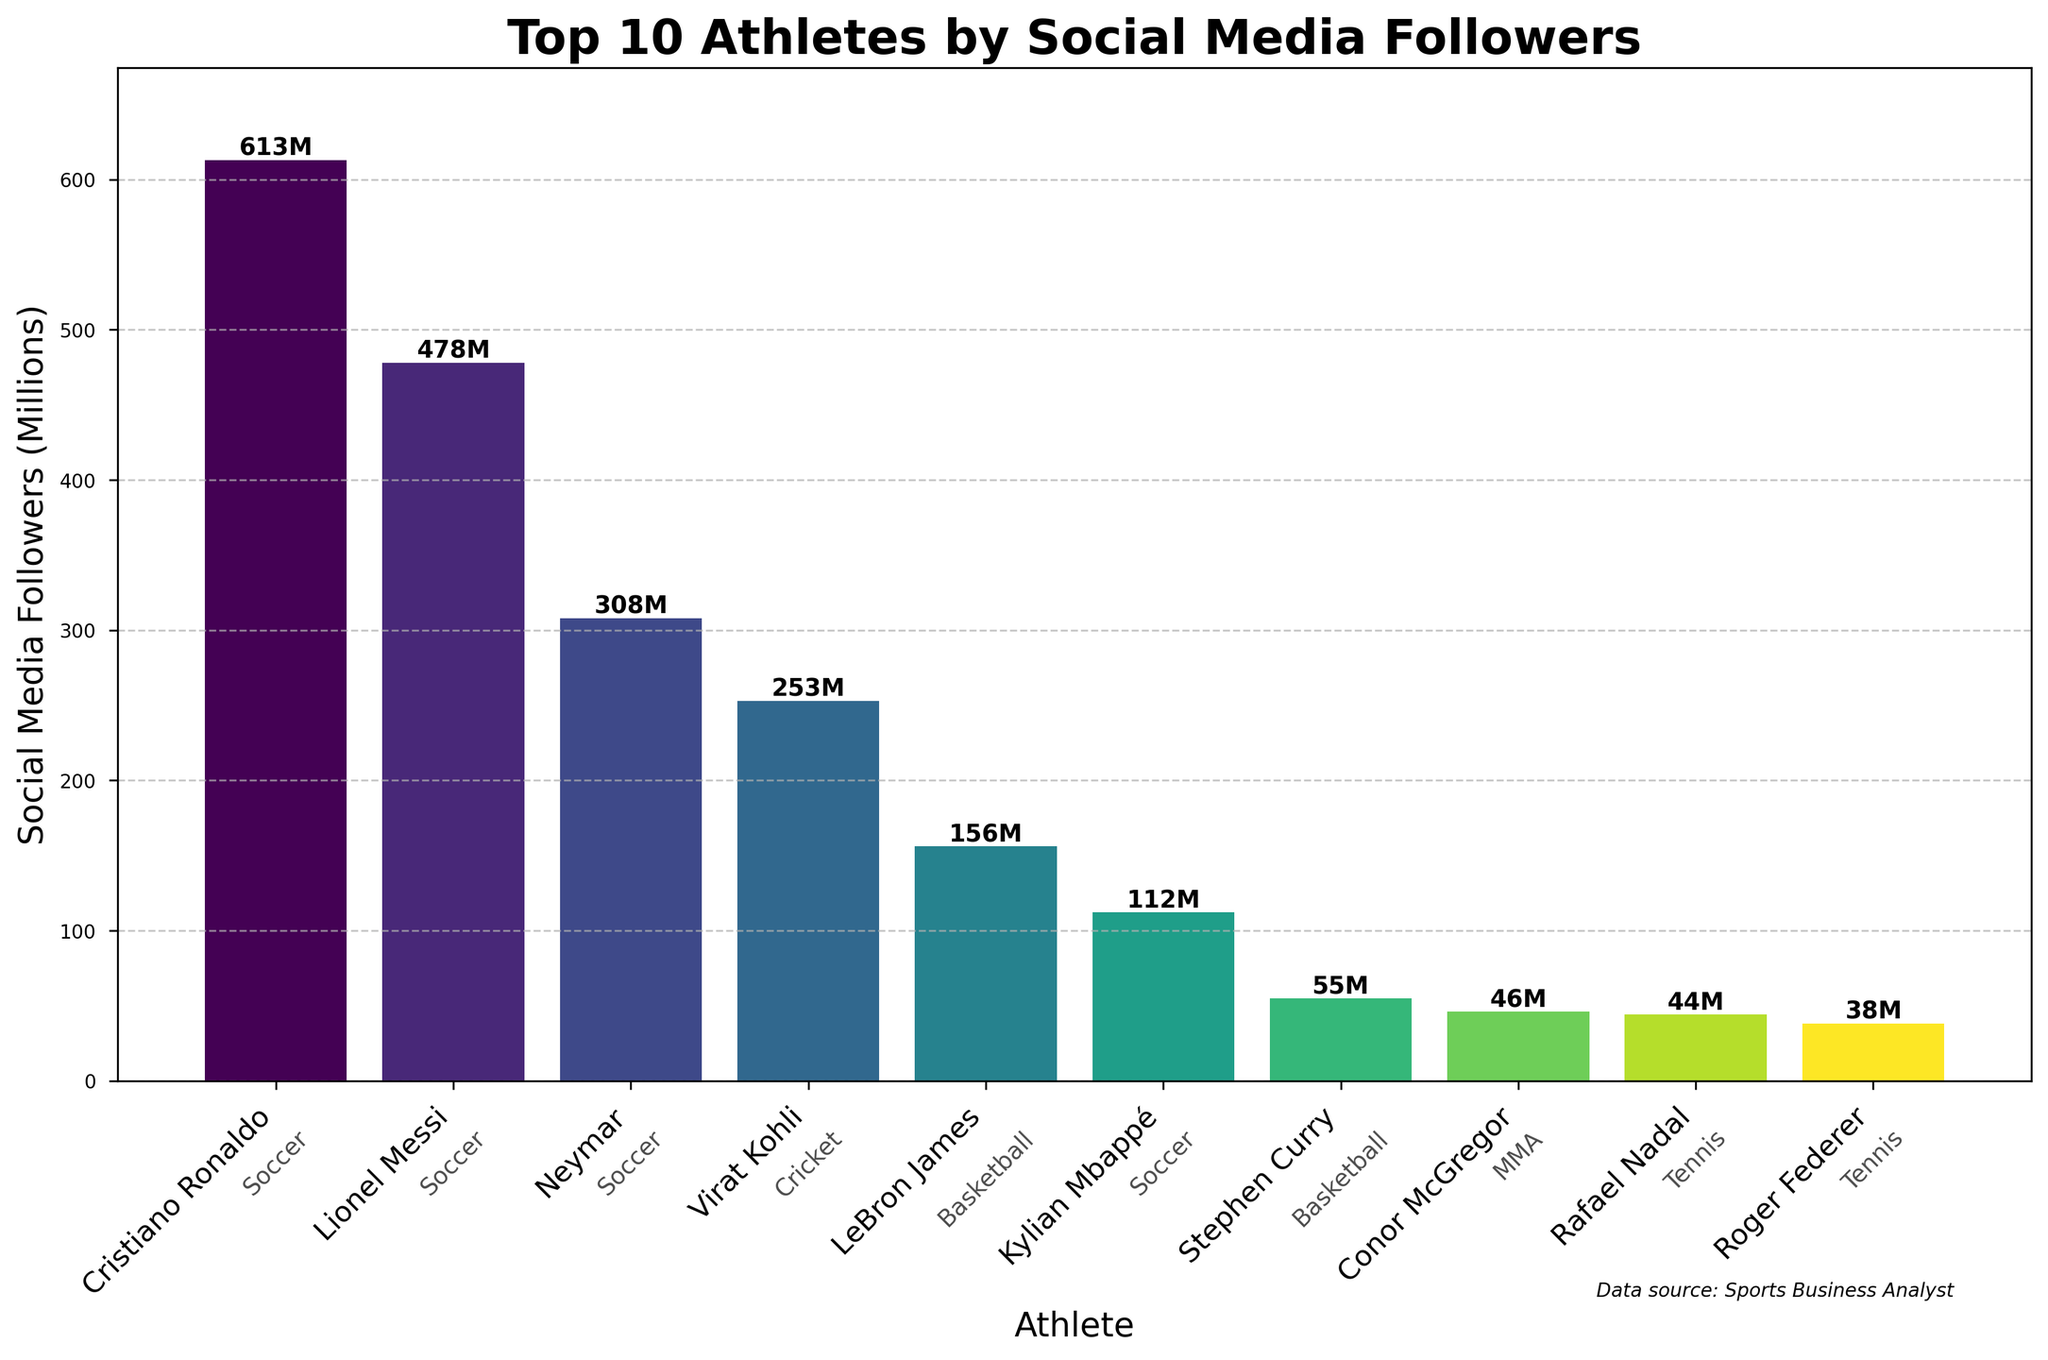Which athlete has the most social media followers? The highest bar in the chart represents Cristiano Ronaldo who has 613 million followers.
Answer: Cristiano Ronaldo Which sport appears most frequently among the top 10 athletes by social media followers? By looking at the sports annotated text at the base of the bars, "Soccer" appears the most frequently. There are four soccer players in the top 10.
Answer: Soccer What is the difference in social media followers between Lionel Messi and Virat Kohli? According to the chart, Lionel Messi has 478 million followers, and Virat Kohli has 253 million. The difference is calculated as 478M - 253M.
Answer: 225 million What’s the combined followers count for all soccer players in the top 10? Summing the followers of Cristiano Ronaldo (613M), Lionel Messi (478M), Neymar (308M), and Kylian Mbappé (112M): 613 + 478 + 308 + 112 = 1511 million.
Answer: 1511 million Which tennis athlete has the least social media followers among the top 10? The shortest bar representing a tennis athlete is for Roger Federer, who has 38 million followers.
Answer: Roger Federer How does LeBron James's follower count compare to Stephen Curry's? LeBron James has 156 million followers while Stephen Curry has 55 million. Thus, LeBron James has more followers than Stephen Curry.
Answer: LeBron James has more followers What is the average follower count of the top 10 athletes? To find the average, sum the followers of the top 10 athletes and divide by 10: (613+478+308+156+253+112+44+38+46+55)/10 = 2103/10 = 210.3 million.
Answer: 210.3 million Which athlete has just under half the followers of the athlete with the most followers? Neymar with 308 million has close to half of Cristiano Ronaldo's 613 million.
Answer: Neymar Are there any female athletes in the top 10? By observing the names and the respective sports, no female athlete appears in the top 10 list for the social media followers.
Answer: No How many sports are represented among the top 10 athletes by social media followers? By counting the unique sports annotated: Soccer, Basketball, Cricket, Tennis, and MMA, there are 5 different sports represented.
Answer: 5 